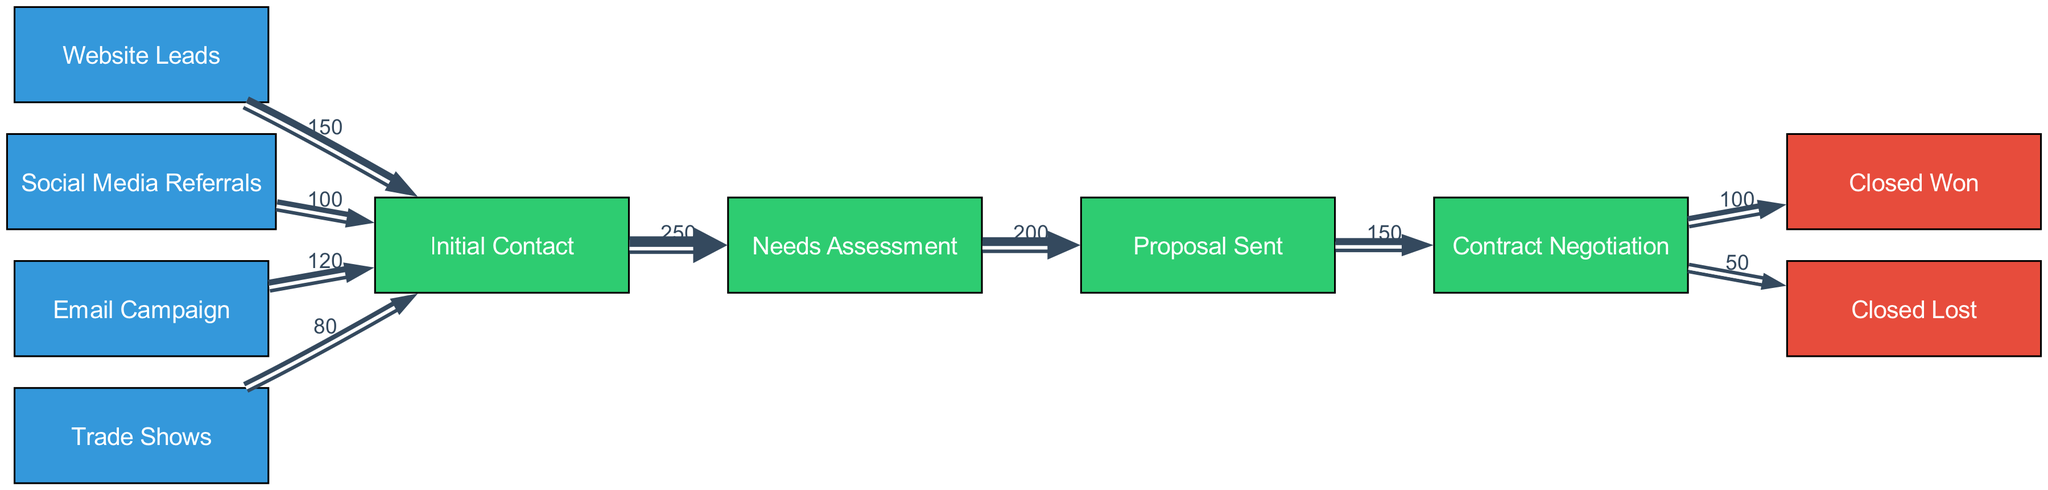What is the total number of lead sources in the diagram? The diagram includes four lead sources: Website Leads, Social Media Referrals, Email Campaign, and Trade Shows. Therefore, to find the total, we count these sources.
Answer: 4 What is the value of leads from Trade Shows going to Initial Contact? In the diagram, the link from Trade Shows to Initial Contact indicates a value of 80. This is explicitly shown as part of the data in the diagram.
Answer: 80 How many stages are represented in the sales funnel? The stages in the funnel are Initial Contact, Needs Assessment, Proposal Sent, and Contract Negotiation. Counting these stages gives us the total number of stages represented.
Answer: 4 What is the conversion rate from Needs Assessment to Proposal Sent? To calculate the conversion rate, we look at the number of leads that moved from Needs Assessment to Proposal Sent (200) and compare it to the number that entered Needs Assessment (250). The conversion rate is 200 out of 250, which simplifies to 80 percent.
Answer: 80 percent Which lead source had the highest number of leads moving to Initial Contact? By examining the connections to Initial Contact, we see that Website Leads has 150 leads, Social Media Referrals has 100, Email Campaign has 120, and Trade Shows has 80. The highest among these is from Website Leads.
Answer: Website Leads How many leads were Closed Lost after Contract Negotiation? From the diagram, the link from Contract Negotiation to Closed Lost shows a value of 50. This gives us the total number of leads that were lost.
Answer: 50 What is the total number of leads that successfully Closed Won? The number of leads that transitioned from Contract Negotiation to Closed Won is indicated in the diagram as 100, which we can directly read from the link.
Answer: 100 What is the total flow of leads entering the Needs Assessment stage? To find the total flow to Needs Assessment, we sum the leads from Initial Contact, which is 250. Therefore, the total flow into Needs Assessment is simply that value.
Answer: 250 What is the total number of leads that progressed to Closed Won and Closed Lost combined? Combining the values from the outcomes Closed Won (100) and Closed Lost (50), we add these figures: 100 + 50 equals 150. This provides the total outcome leads combined.
Answer: 150 